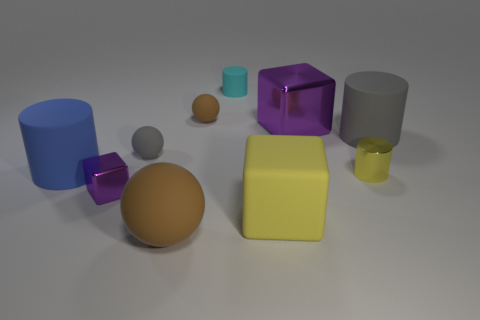If these objects were part of a child's playset, which educational aspects could they be used to teach? These objects could serve multiple educational purposes in a child's playset. They could be used to teach about geometric shapes, like spheres, cubes, and cylinders. Colors education would also be well-served with this set, introducing children to blue, brown, purple, yellow, and grey. Additionally, they could be used in lessons about spatial reasoning, sorting, and grouping by attributes such as size and color. 